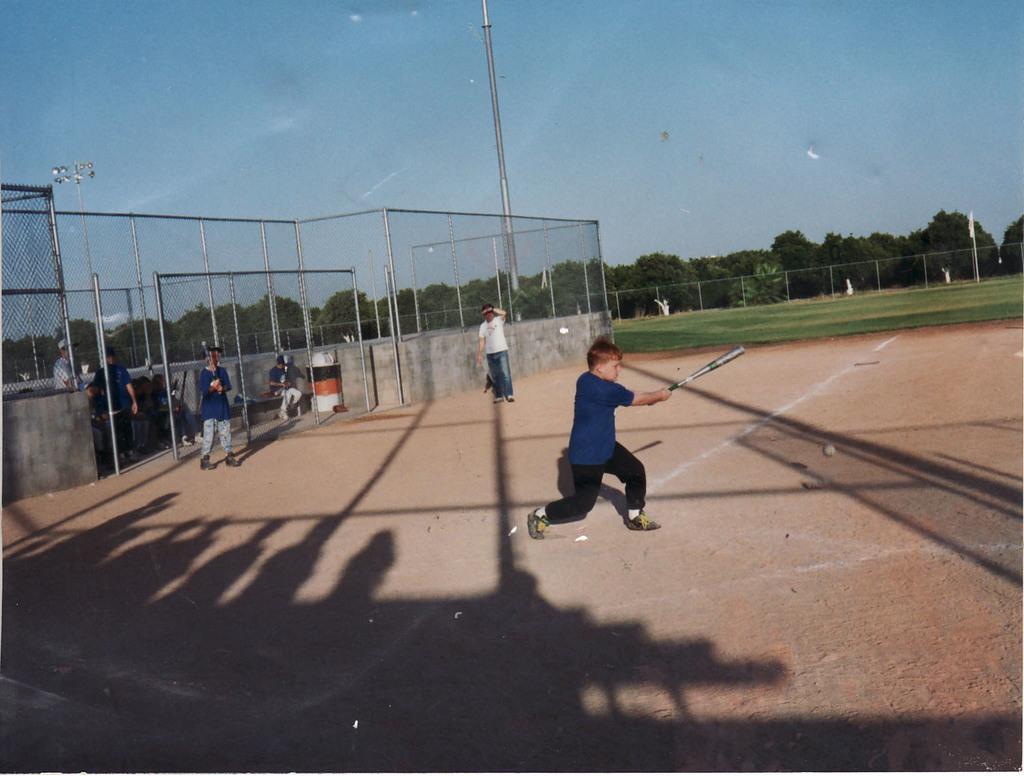In one or two sentences, can you explain what this image depicts? In this image we can see some group of persons playing baseball in the ground by holding some baseball sticks in their hands and in the background of the image there is fencing, some trees and top of the image there is clear sky. 